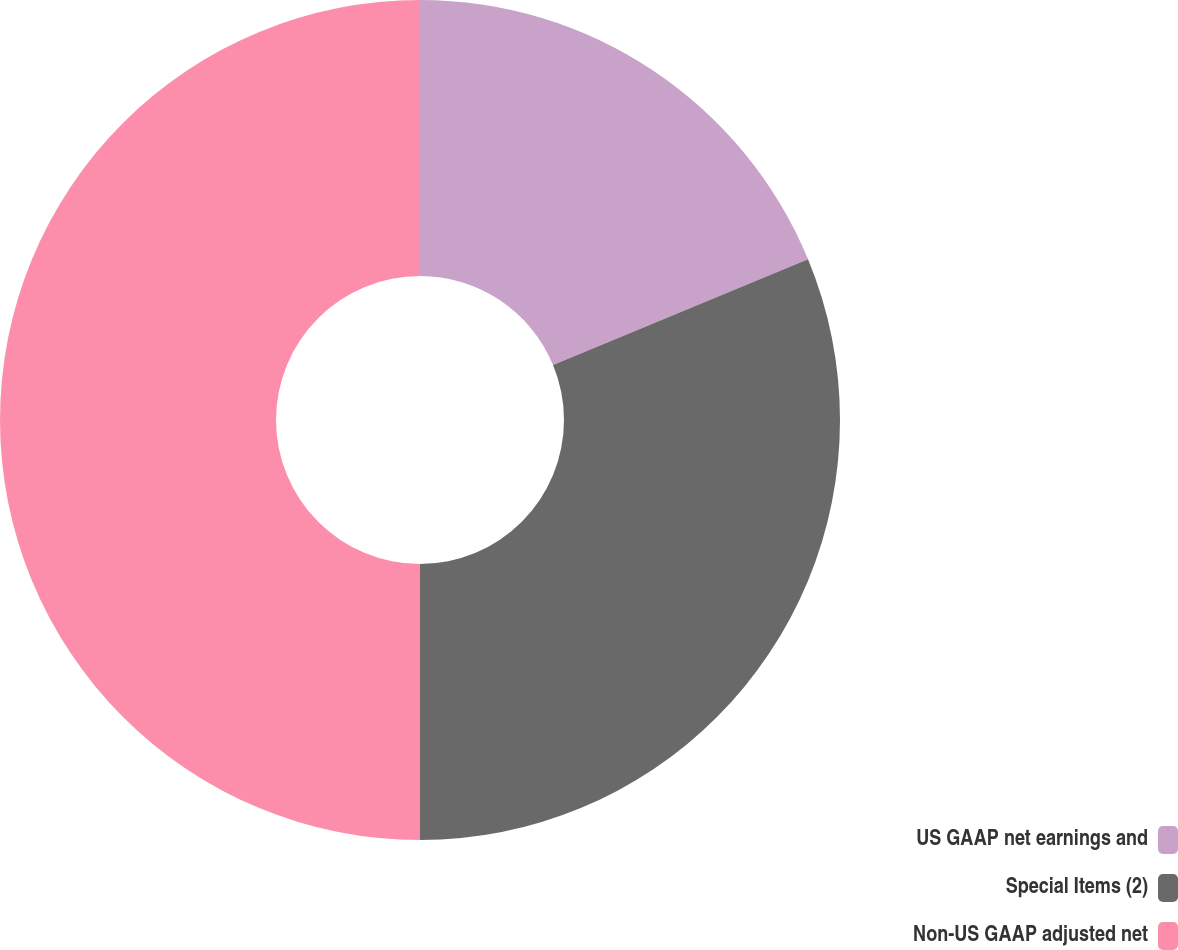<chart> <loc_0><loc_0><loc_500><loc_500><pie_chart><fcel>US GAAP net earnings and<fcel>Special Items (2)<fcel>Non-US GAAP adjusted net<nl><fcel>18.75%<fcel>31.25%<fcel>50.0%<nl></chart> 